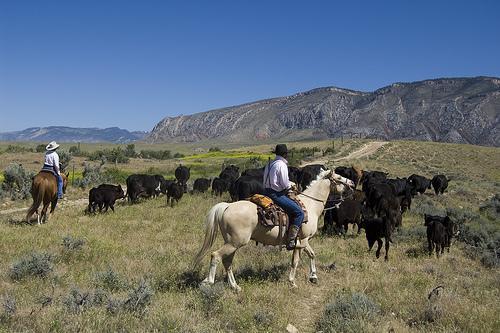How many men are on horses?
Give a very brief answer. 2. How many white cowboy hats are in this picture?
Give a very brief answer. 1. 